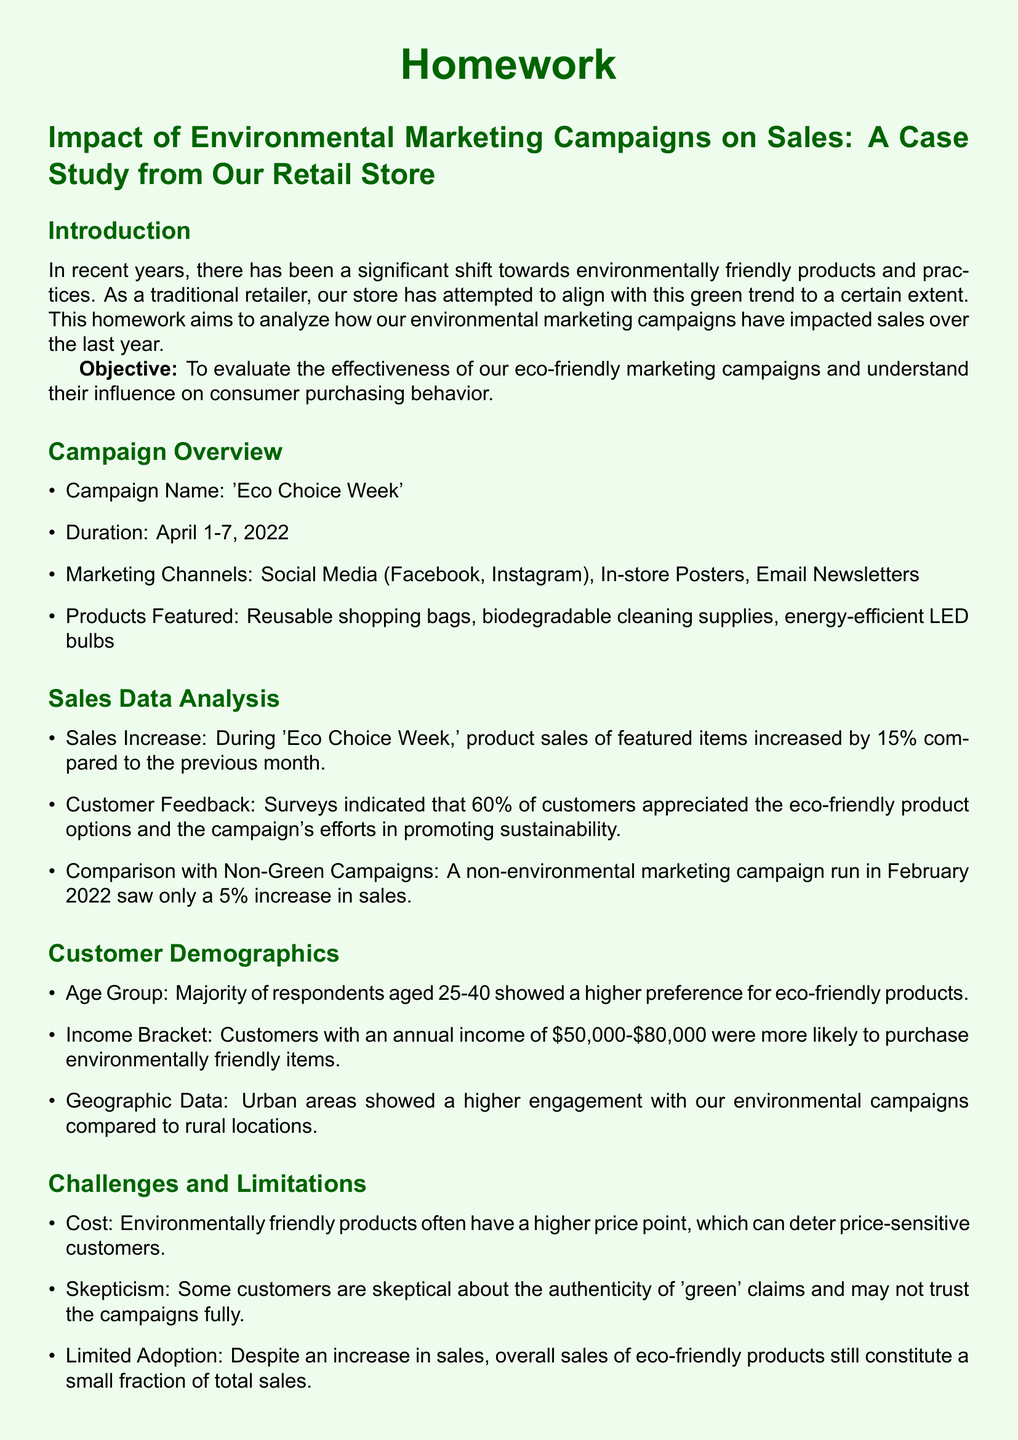What was the duration of the 'Eco Choice Week' campaign? The document states that the campaign ran from April 1-7, 2022.
Answer: April 1-7, 2022 What percentage increase in sales was observed during the 'Eco Choice Week'? The sales increase during the campaign was noted to be 15% compared to the previous month.
Answer: 15% Which marketing channels were used for the environmental campaign? The document lists Social Media (Facebook, Instagram), In-store Posters, and Email Newsletters as the marketing channels.
Answer: Social Media, In-store Posters, Email Newsletters What demographic group showed a higher preference for eco-friendly products? According to the document, the age group that showed a higher preference was between 25-40.
Answer: 25-40 What challenges are associated with environmentally friendly products? The document mentions cost, skepticism, and limited adoption as challenges faced.
Answer: Cost, skepticism, limited adoption What product type had the greatest sales increase compared to the non-green campaign? The 'Eco Choice Week' features included reusable shopping bags, which contributed to the sales spike.
Answer: Reusable shopping bags How did urban areas respond compared to rural areas regarding the campaign? The document indicates that urban areas showed higher engagement with environmental campaigns than rural locations.
Answer: Higher engagement What recommendation is made regarding the product range? It is suggested to expand the product range to introduce a wider variety of eco-friendly products.
Answer: Expand product range 